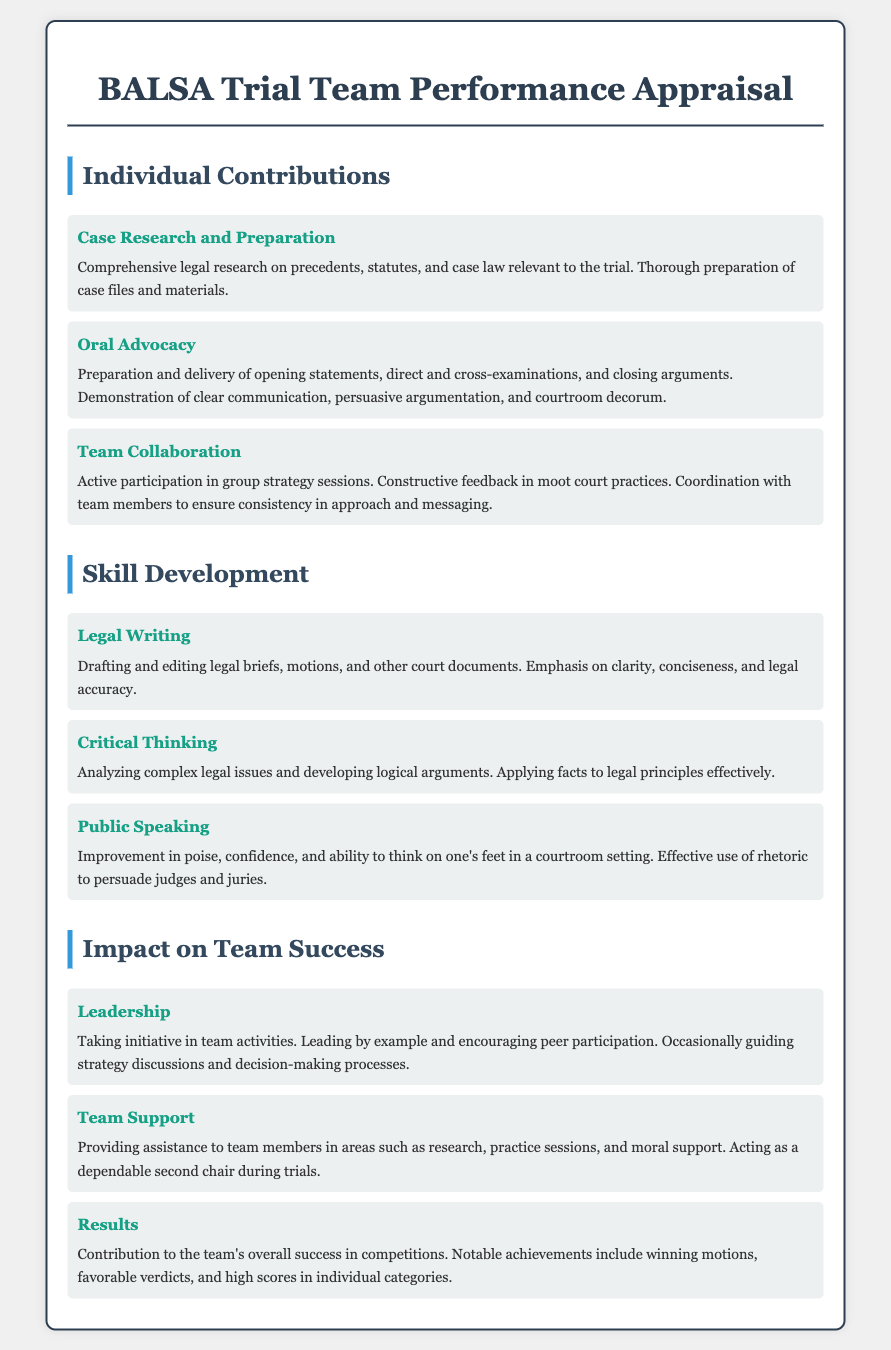What are the sections of the appraisal form? The sections listed in the appraisal form are "Individual Contributions," "Skill Development," and "Impact on Team Success."
Answer: Individual Contributions, Skill Development, Impact on Team Success What is one area covered under Individual Contributions? Individual Contributions section includes "Case Research and Preparation," which involves comprehensive legal research and preparation of case files.
Answer: Case Research and Preparation What skill is emphasized under Skill Development? The Skill Development section emphasizes "Legal Writing," focusing on drafting and editing legal briefs with clarity and accuracy.
Answer: Legal Writing How does the appraisal form describe the role of "Leadership"? Leadership in the Impact on Team Success section involves taking initiative in team activities and guiding strategy discussions.
Answer: Taking initiative in team activities What is the impact of the team's efforts as stated in the Results section? The Results section specifies that the team achieved notable successes such as winning motions and favorable verdicts in competitions.
Answer: Winning motions, favorable verdicts What type of support does the document suggest is provided under Team Support? The Team Support section indicates providing assistance in research and practice sessions, along with moral support to teammates.
Answer: Assistance in research, practice sessions, moral support 